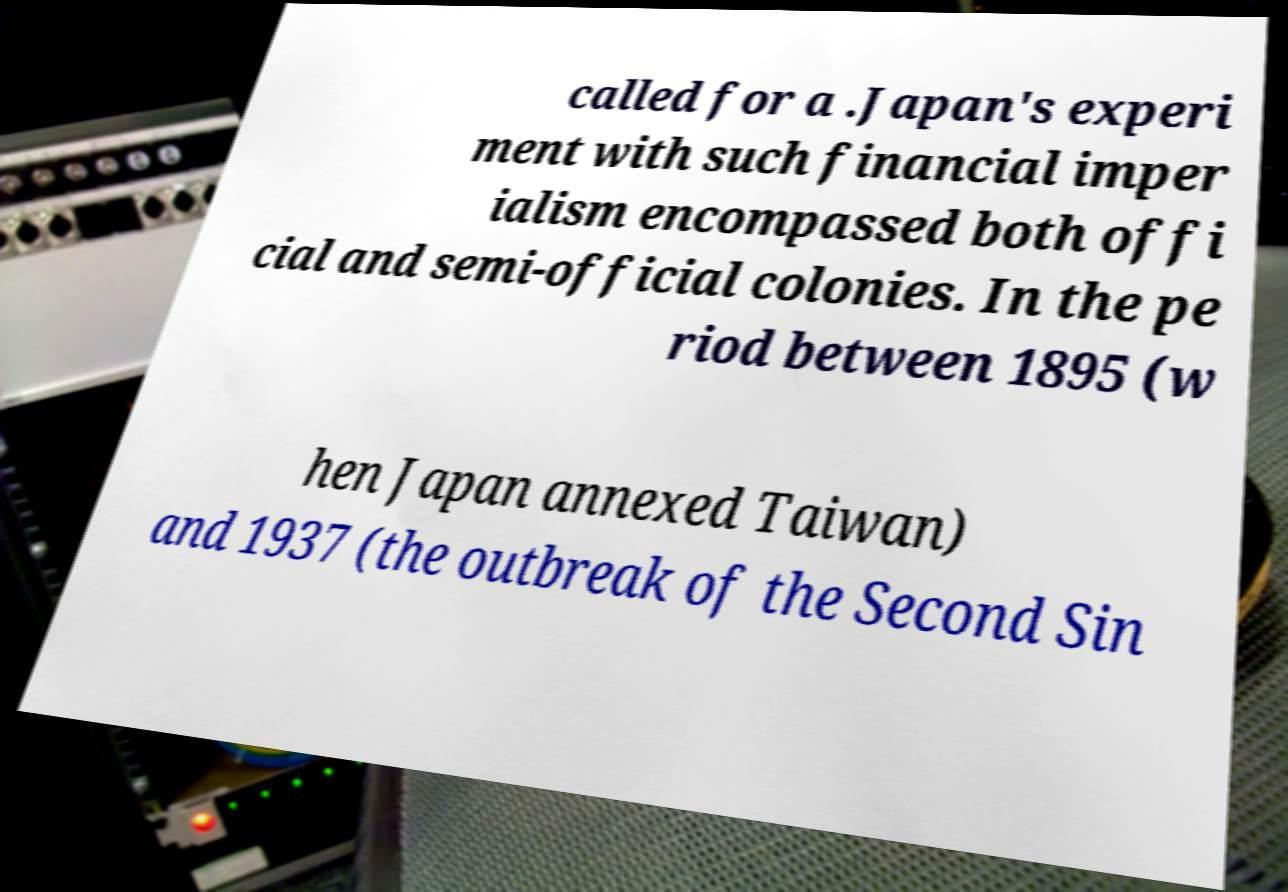For documentation purposes, I need the text within this image transcribed. Could you provide that? called for a .Japan's experi ment with such financial imper ialism encompassed both offi cial and semi-official colonies. In the pe riod between 1895 (w hen Japan annexed Taiwan) and 1937 (the outbreak of the Second Sin 